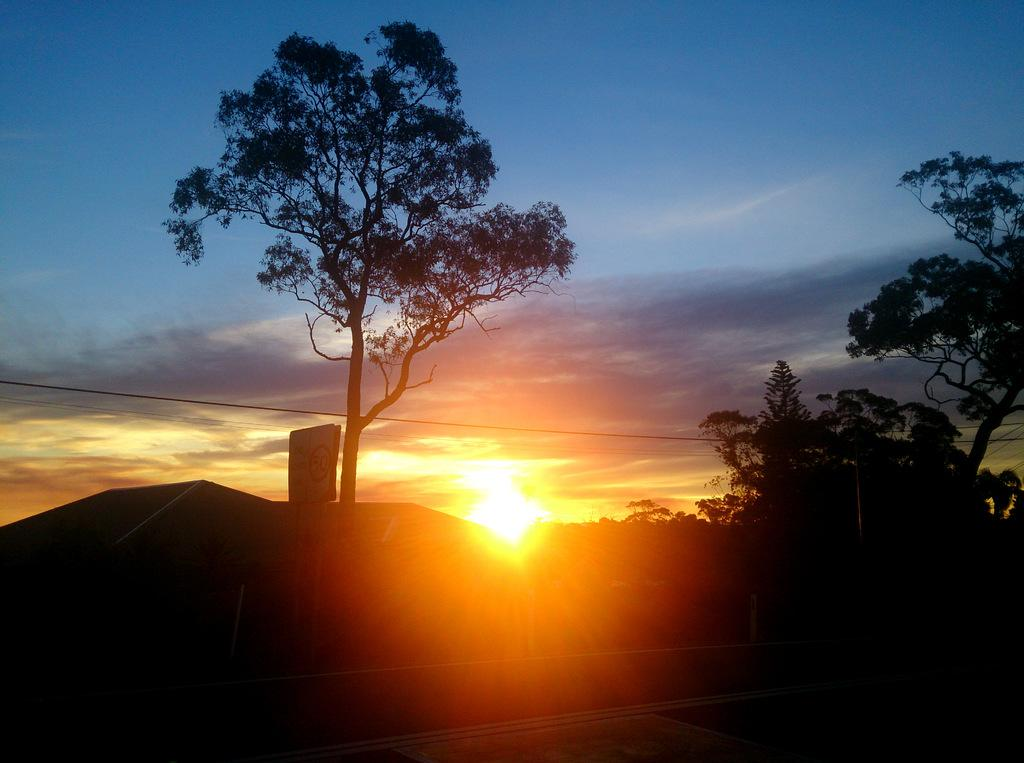What type of natural elements can be seen in the image? There are trees in the image. What structure is present in the image with a sign board? There is a pole with a sign board in the image. What can be seen in the sky in the image? The sky is visible in the image, and the sun is observable in it. What else can be seen in the image related to infrastructure? There are wires in the image. What type of dolls are sitting on the bench in the image? There are no dolls present in the image. What drink is the judge holding in the image? There is no judge or drink present in the image. 